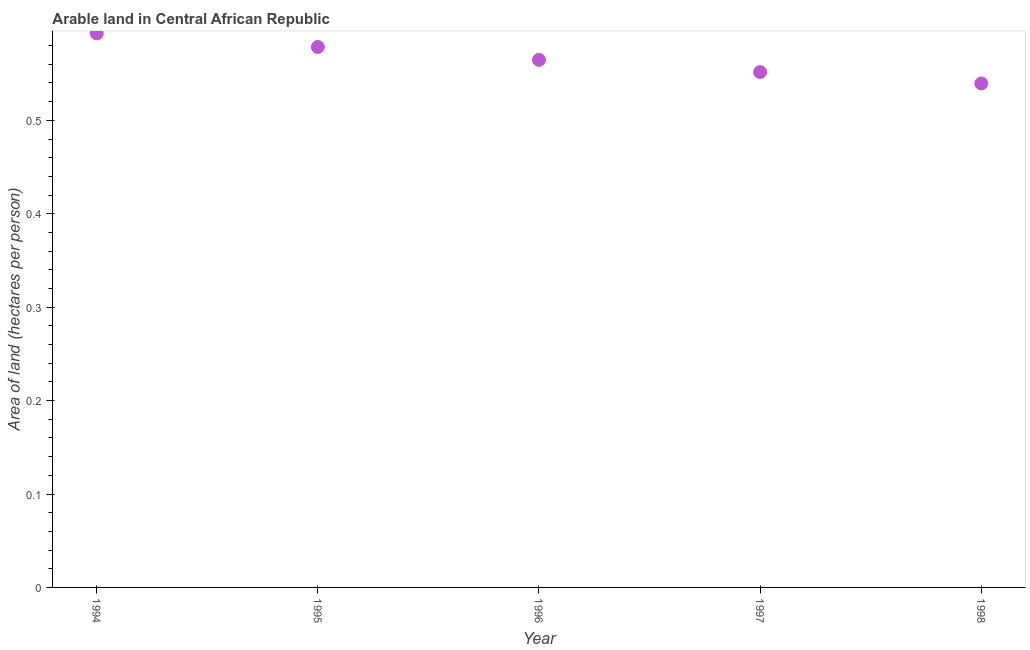What is the area of arable land in 1995?
Ensure brevity in your answer.  0.58. Across all years, what is the maximum area of arable land?
Ensure brevity in your answer.  0.59. Across all years, what is the minimum area of arable land?
Offer a terse response. 0.54. In which year was the area of arable land maximum?
Keep it short and to the point. 1994. In which year was the area of arable land minimum?
Your answer should be very brief. 1998. What is the sum of the area of arable land?
Provide a succinct answer. 2.83. What is the difference between the area of arable land in 1994 and 1998?
Offer a very short reply. 0.05. What is the average area of arable land per year?
Keep it short and to the point. 0.57. What is the median area of arable land?
Offer a very short reply. 0.56. What is the ratio of the area of arable land in 1996 to that in 1997?
Ensure brevity in your answer.  1.02. What is the difference between the highest and the second highest area of arable land?
Offer a terse response. 0.01. Is the sum of the area of arable land in 1994 and 1995 greater than the maximum area of arable land across all years?
Provide a short and direct response. Yes. What is the difference between the highest and the lowest area of arable land?
Offer a very short reply. 0.05. In how many years, is the area of arable land greater than the average area of arable land taken over all years?
Make the answer very short. 2. Does the area of arable land monotonically increase over the years?
Offer a very short reply. No. Are the values on the major ticks of Y-axis written in scientific E-notation?
Your response must be concise. No. Does the graph contain any zero values?
Your response must be concise. No. What is the title of the graph?
Make the answer very short. Arable land in Central African Republic. What is the label or title of the Y-axis?
Make the answer very short. Area of land (hectares per person). What is the Area of land (hectares per person) in 1994?
Give a very brief answer. 0.59. What is the Area of land (hectares per person) in 1995?
Give a very brief answer. 0.58. What is the Area of land (hectares per person) in 1996?
Offer a very short reply. 0.56. What is the Area of land (hectares per person) in 1997?
Offer a very short reply. 0.55. What is the Area of land (hectares per person) in 1998?
Make the answer very short. 0.54. What is the difference between the Area of land (hectares per person) in 1994 and 1995?
Your answer should be very brief. 0.01. What is the difference between the Area of land (hectares per person) in 1994 and 1996?
Offer a terse response. 0.03. What is the difference between the Area of land (hectares per person) in 1994 and 1997?
Give a very brief answer. 0.04. What is the difference between the Area of land (hectares per person) in 1994 and 1998?
Offer a very short reply. 0.05. What is the difference between the Area of land (hectares per person) in 1995 and 1996?
Your answer should be compact. 0.01. What is the difference between the Area of land (hectares per person) in 1995 and 1997?
Your answer should be very brief. 0.03. What is the difference between the Area of land (hectares per person) in 1995 and 1998?
Your answer should be compact. 0.04. What is the difference between the Area of land (hectares per person) in 1996 and 1997?
Provide a short and direct response. 0.01. What is the difference between the Area of land (hectares per person) in 1996 and 1998?
Your answer should be compact. 0.03. What is the difference between the Area of land (hectares per person) in 1997 and 1998?
Provide a succinct answer. 0.01. What is the ratio of the Area of land (hectares per person) in 1994 to that in 1995?
Keep it short and to the point. 1.02. What is the ratio of the Area of land (hectares per person) in 1994 to that in 1996?
Your answer should be very brief. 1.05. What is the ratio of the Area of land (hectares per person) in 1994 to that in 1997?
Ensure brevity in your answer.  1.07. What is the ratio of the Area of land (hectares per person) in 1994 to that in 1998?
Offer a very short reply. 1.1. What is the ratio of the Area of land (hectares per person) in 1995 to that in 1997?
Your answer should be compact. 1.05. What is the ratio of the Area of land (hectares per person) in 1995 to that in 1998?
Offer a very short reply. 1.07. What is the ratio of the Area of land (hectares per person) in 1996 to that in 1997?
Offer a very short reply. 1.02. What is the ratio of the Area of land (hectares per person) in 1996 to that in 1998?
Make the answer very short. 1.05. 